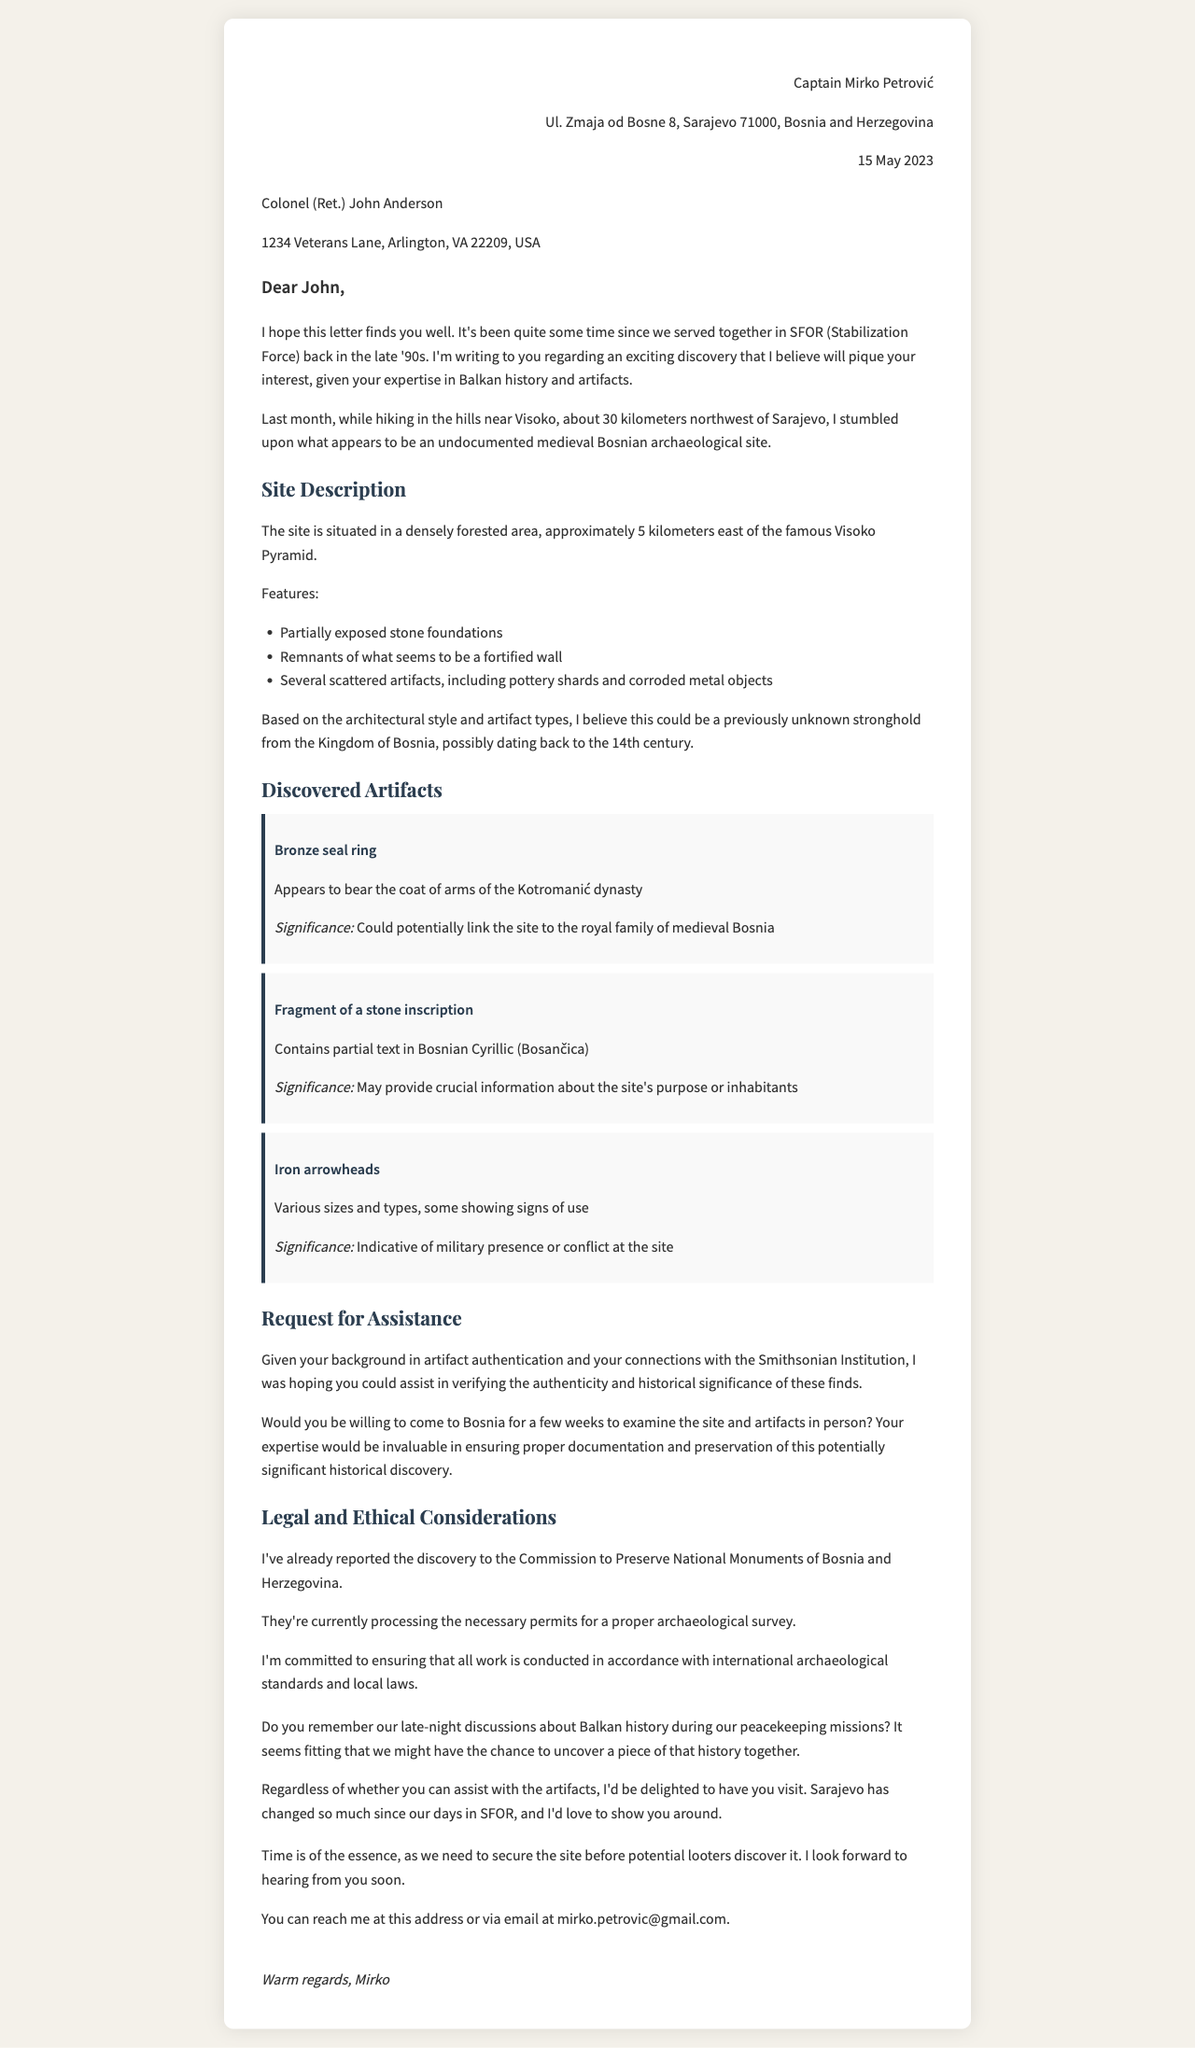what is the name of the sender? The sender of the letter is introduced in the letter header as Captain Mirko Petrović.
Answer: Captain Mirko Petrović what is the date of the letter? The date is mentioned in the letter header under the letter details.
Answer: 15 May 2023 where was the archaeological site discovered? The location of the discovery is noted in the introduction paragraph, specifically mentioning the hills near Visoko.
Answer: near Visoko what kind of artifacts were discovered? The letter lists several artifacts indicating specific types found at the site.
Answer: Bronze seal ring, fragment of a stone inscription, iron arrowheads what is the significance of the bronze seal ring? The letter mentions its importance regarding the connection to a historical royal family.
Answer: could potentially link the site to the royal family of medieval Bosnia who is the recipient of the letter? The recipient's name and address are provided in the letter body.
Answer: Colonel (Ret.) John Anderson what was reported to the Commission to Preserve National Monuments? The letter states a specific action taken regarding the archaeological discovery.
Answer: the discovery what is the urgency noted in the closing remarks? The letter emphasizes a concern that speaks to the need for immediate action.
Answer: Time is of the essence why does Captain Mirko Petrović want Colonel Anderson's assistance? The letter explains the expertise and connections that are important for artifact evaluation.
Answer: verifying the authenticity and historical significance of these finds what invitation does Mirko extend to John Anderson? The personal note includes an invitation that reflects their shared past and current situation.
Answer: to visit Sarajevo 